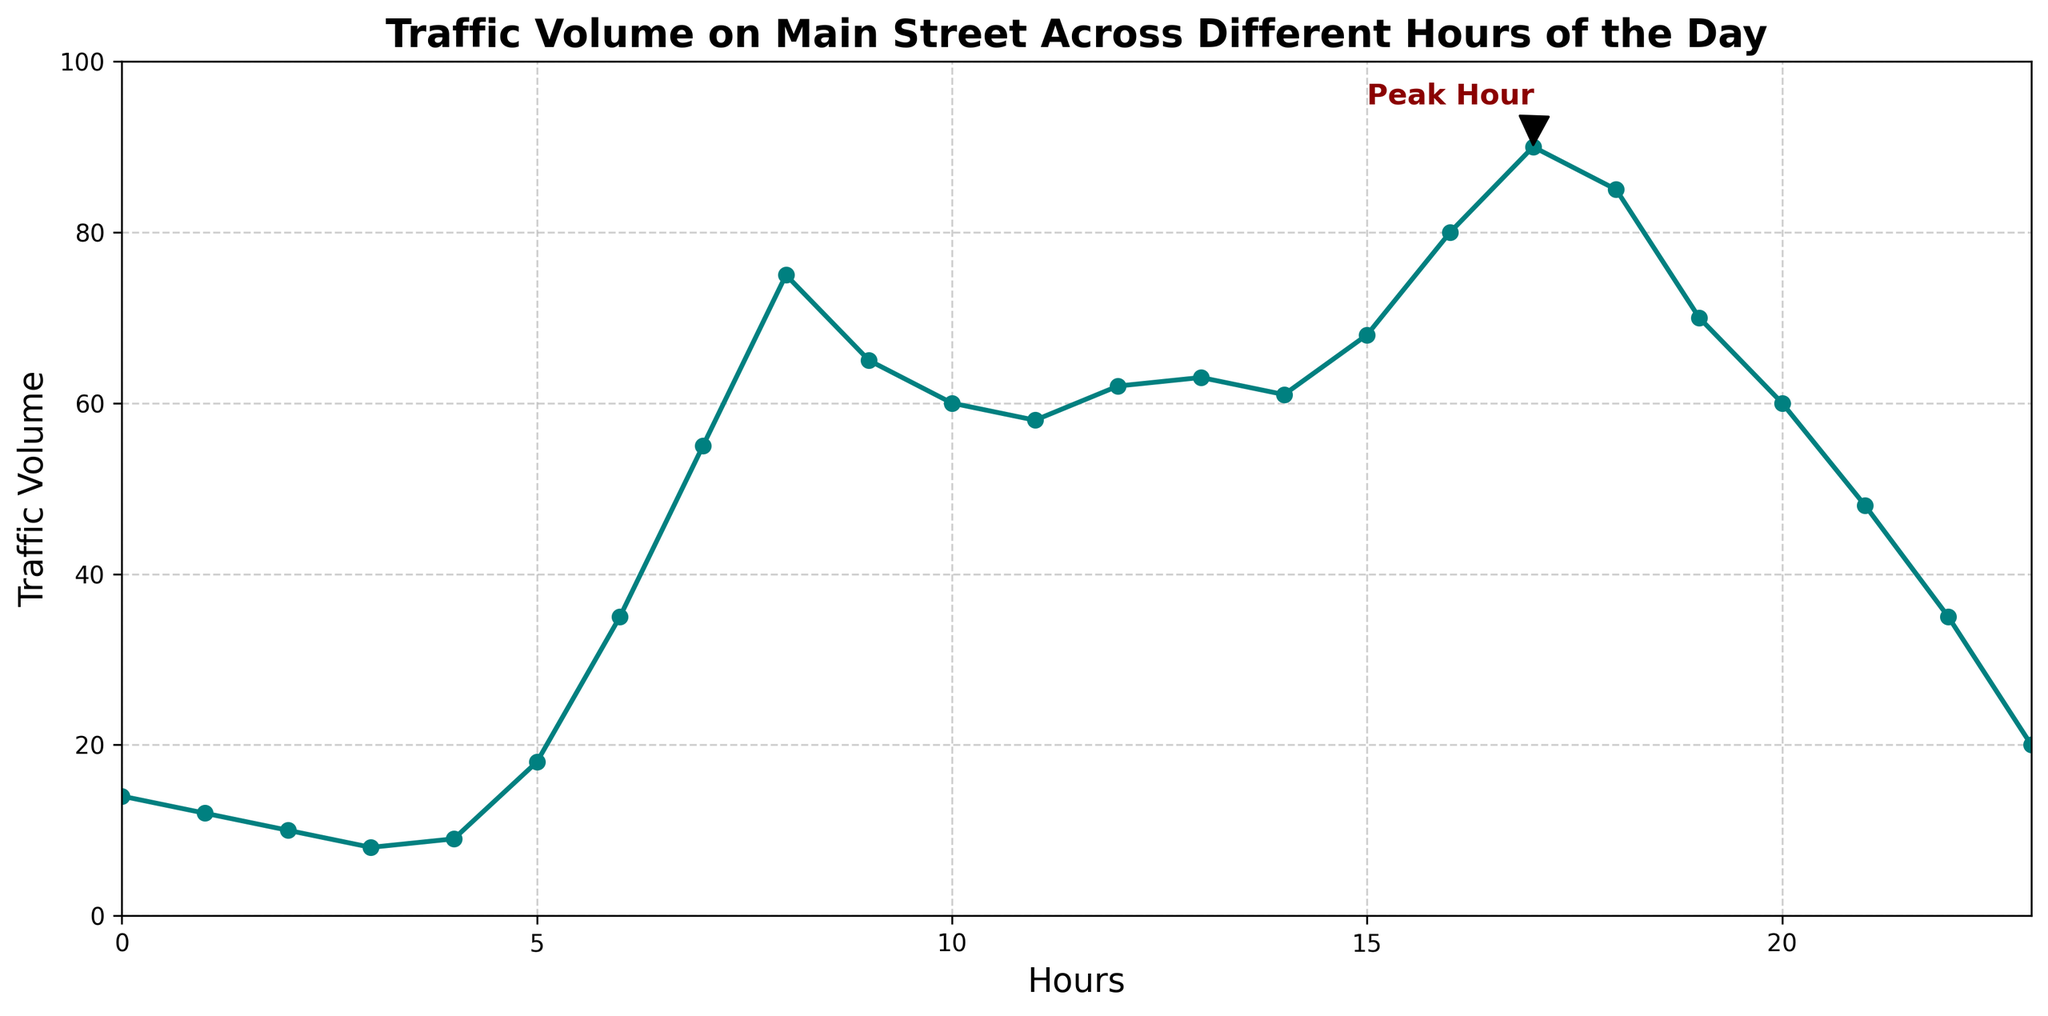What time does the traffic volume peak according to the figure? The plot has an annotation labeled 'Peak Hour' at 17:00 (5 PM), with the highest traffic volume of 90.
Answer: 17:00 At what hour is the traffic volume the lowest, and what is that volume? The traffic volume is lowest at 3:00 (3 AM) with a volume of 8, as seen on the graph where the line is at its lowest point.
Answer: 3:00, 8 How does the traffic volume at 8:00 compare to the volume at 18:00? At 8:00, the traffic volume is 75, and at 18:00, it is 85. By comparing these two values, we see that the volume at 18:00 is higher.
Answer: 18:00 has higher traffic volume than 8:00 What is the average traffic volume between 16:00 and 20:00? Add the traffic volumes at 16:00, 17:00, 18:00, 19:00, and 20:00 then divide by 5: (80 + 90 + 85 + 70 + 60) / 5 = 77
Answer: 77 In which two hours does the traffic volume first exceed 50 and then drop below 20? Traffic first exceeds 50 at 7:00, with a volume of 55, and drops below 20 at 23:00, with a volume of 20.
Answer: 7:00 and 23:00 What is the total traffic volume for the hours between midnight and 5:00? Add traffic volumes from 0:00 to 5:00: 14 + 12 + 10 + 8 + 9 + 18 = 71
Answer: 71 Is there a noticeable trend in traffic volume throughout the day? Yes, traffic volume generally increases from early morning hours, peaking around 17:00, and then decreases gradually until late at night.
Answer: Yes 